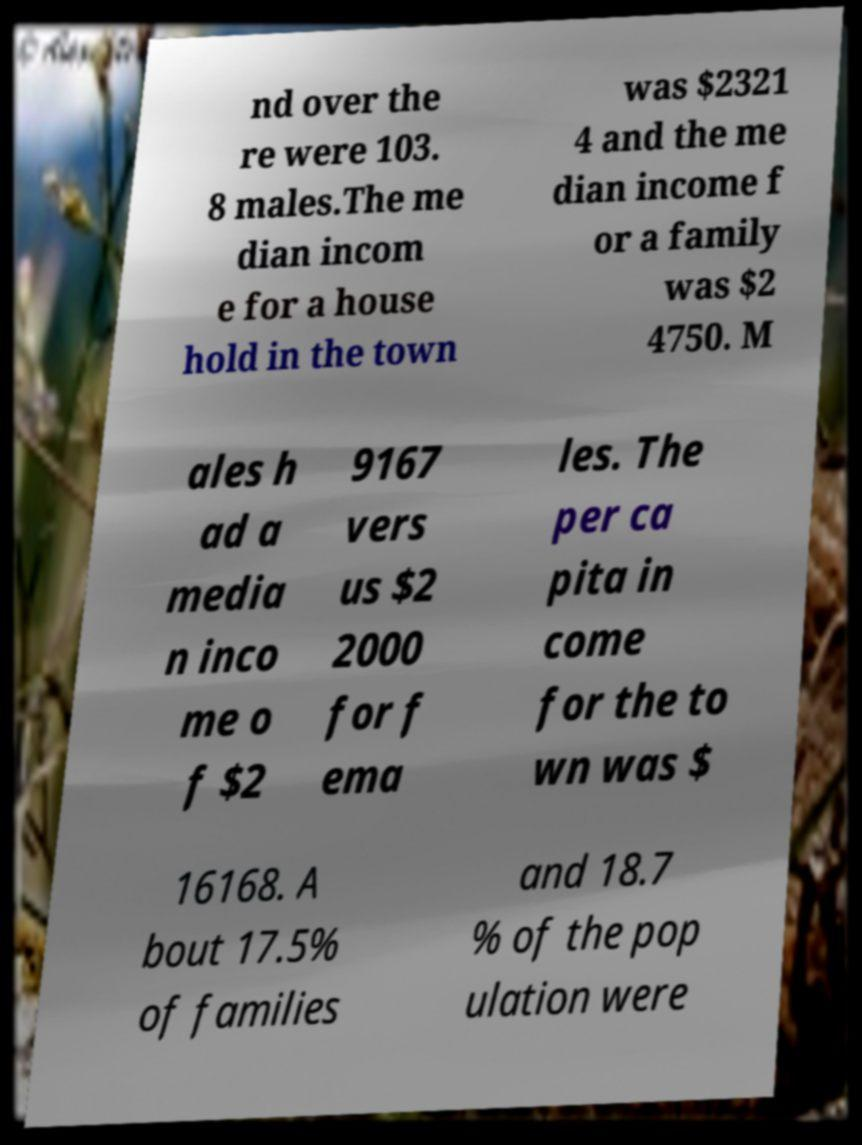There's text embedded in this image that I need extracted. Can you transcribe it verbatim? nd over the re were 103. 8 males.The me dian incom e for a house hold in the town was $2321 4 and the me dian income f or a family was $2 4750. M ales h ad a media n inco me o f $2 9167 vers us $2 2000 for f ema les. The per ca pita in come for the to wn was $ 16168. A bout 17.5% of families and 18.7 % of the pop ulation were 